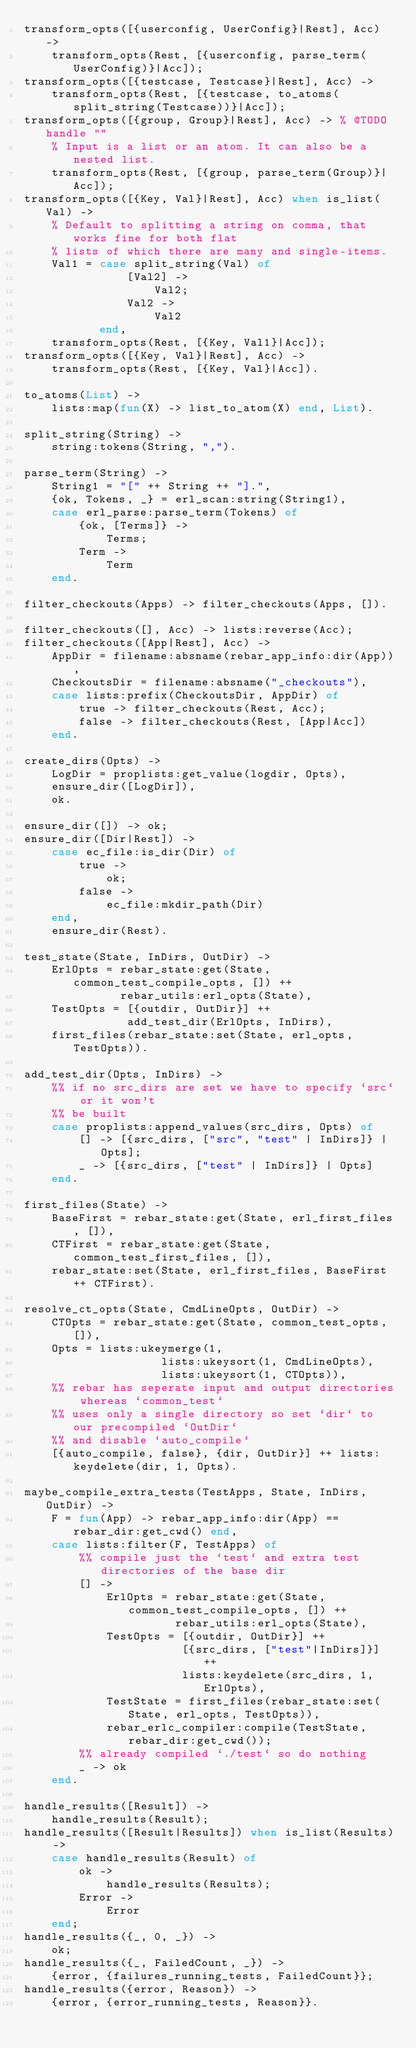Convert code to text. <code><loc_0><loc_0><loc_500><loc_500><_Erlang_>transform_opts([{userconfig, UserConfig}|Rest], Acc) ->
    transform_opts(Rest, [{userconfig, parse_term(UserConfig)}|Acc]);
transform_opts([{testcase, Testcase}|Rest], Acc) ->
    transform_opts(Rest, [{testcase, to_atoms(split_string(Testcase))}|Acc]);
transform_opts([{group, Group}|Rest], Acc) -> % @TODO handle ""
    % Input is a list or an atom. It can also be a nested list.
    transform_opts(Rest, [{group, parse_term(Group)}|Acc]);
transform_opts([{Key, Val}|Rest], Acc) when is_list(Val) ->
    % Default to splitting a string on comma, that works fine for both flat
    % lists of which there are many and single-items.
    Val1 = case split_string(Val) of
               [Val2] ->
                   Val2;
               Val2 ->
                   Val2
           end,
    transform_opts(Rest, [{Key, Val1}|Acc]);
transform_opts([{Key, Val}|Rest], Acc) ->
    transform_opts(Rest, [{Key, Val}|Acc]).

to_atoms(List) ->
    lists:map(fun(X) -> list_to_atom(X) end, List).

split_string(String) ->
    string:tokens(String, ",").

parse_term(String) ->
    String1 = "[" ++ String ++ "].",
    {ok, Tokens, _} = erl_scan:string(String1),
    case erl_parse:parse_term(Tokens) of
        {ok, [Terms]} ->
            Terms;
        Term ->
            Term
    end.

filter_checkouts(Apps) -> filter_checkouts(Apps, []).

filter_checkouts([], Acc) -> lists:reverse(Acc);
filter_checkouts([App|Rest], Acc) ->
    AppDir = filename:absname(rebar_app_info:dir(App)),
    CheckoutsDir = filename:absname("_checkouts"),
    case lists:prefix(CheckoutsDir, AppDir) of
        true -> filter_checkouts(Rest, Acc);
        false -> filter_checkouts(Rest, [App|Acc])
    end.

create_dirs(Opts) ->
    LogDir = proplists:get_value(logdir, Opts),
    ensure_dir([LogDir]),
    ok.

ensure_dir([]) -> ok;
ensure_dir([Dir|Rest]) ->
    case ec_file:is_dir(Dir) of
        true ->
            ok;
        false ->
            ec_file:mkdir_path(Dir)
    end,
    ensure_dir(Rest).

test_state(State, InDirs, OutDir) ->
    ErlOpts = rebar_state:get(State, common_test_compile_opts, []) ++
              rebar_utils:erl_opts(State),
    TestOpts = [{outdir, OutDir}] ++
               add_test_dir(ErlOpts, InDirs),
    first_files(rebar_state:set(State, erl_opts, TestOpts)).

add_test_dir(Opts, InDirs) ->
    %% if no src_dirs are set we have to specify `src` or it won't
    %% be built
    case proplists:append_values(src_dirs, Opts) of
        [] -> [{src_dirs, ["src", "test" | InDirs]} | Opts];
        _ -> [{src_dirs, ["test" | InDirs]} | Opts]
    end.

first_files(State) ->
    BaseFirst = rebar_state:get(State, erl_first_files, []),
    CTFirst = rebar_state:get(State, common_test_first_files, []),
    rebar_state:set(State, erl_first_files, BaseFirst ++ CTFirst).

resolve_ct_opts(State, CmdLineOpts, OutDir) ->
    CTOpts = rebar_state:get(State, common_test_opts, []),
    Opts = lists:ukeymerge(1,
                    lists:ukeysort(1, CmdLineOpts),
                    lists:ukeysort(1, CTOpts)),
    %% rebar has seperate input and output directories whereas `common_test`
    %% uses only a single directory so set `dir` to our precompiled `OutDir`
    %% and disable `auto_compile`
    [{auto_compile, false}, {dir, OutDir}] ++ lists:keydelete(dir, 1, Opts).

maybe_compile_extra_tests(TestApps, State, InDirs, OutDir) ->
    F = fun(App) -> rebar_app_info:dir(App) == rebar_dir:get_cwd() end,
    case lists:filter(F, TestApps) of
        %% compile just the `test` and extra test directories of the base dir
        [] ->
            ErlOpts = rebar_state:get(State, common_test_compile_opts, []) ++
                      rebar_utils:erl_opts(State),
            TestOpts = [{outdir, OutDir}] ++
                       [{src_dirs, ["test"|InDirs]}] ++
                       lists:keydelete(src_dirs, 1, ErlOpts),
            TestState = first_files(rebar_state:set(State, erl_opts, TestOpts)),
            rebar_erlc_compiler:compile(TestState, rebar_dir:get_cwd());
        %% already compiled `./test` so do nothing
        _ -> ok
    end.

handle_results([Result]) ->
    handle_results(Result);
handle_results([Result|Results]) when is_list(Results) ->
    case handle_results(Result) of
        ok ->
            handle_results(Results);
        Error ->
            Error
    end;
handle_results({_, 0, _}) ->
    ok;
handle_results({_, FailedCount, _}) ->
    {error, {failures_running_tests, FailedCount}};
handle_results({error, Reason}) ->
    {error, {error_running_tests, Reason}}.
</code> 